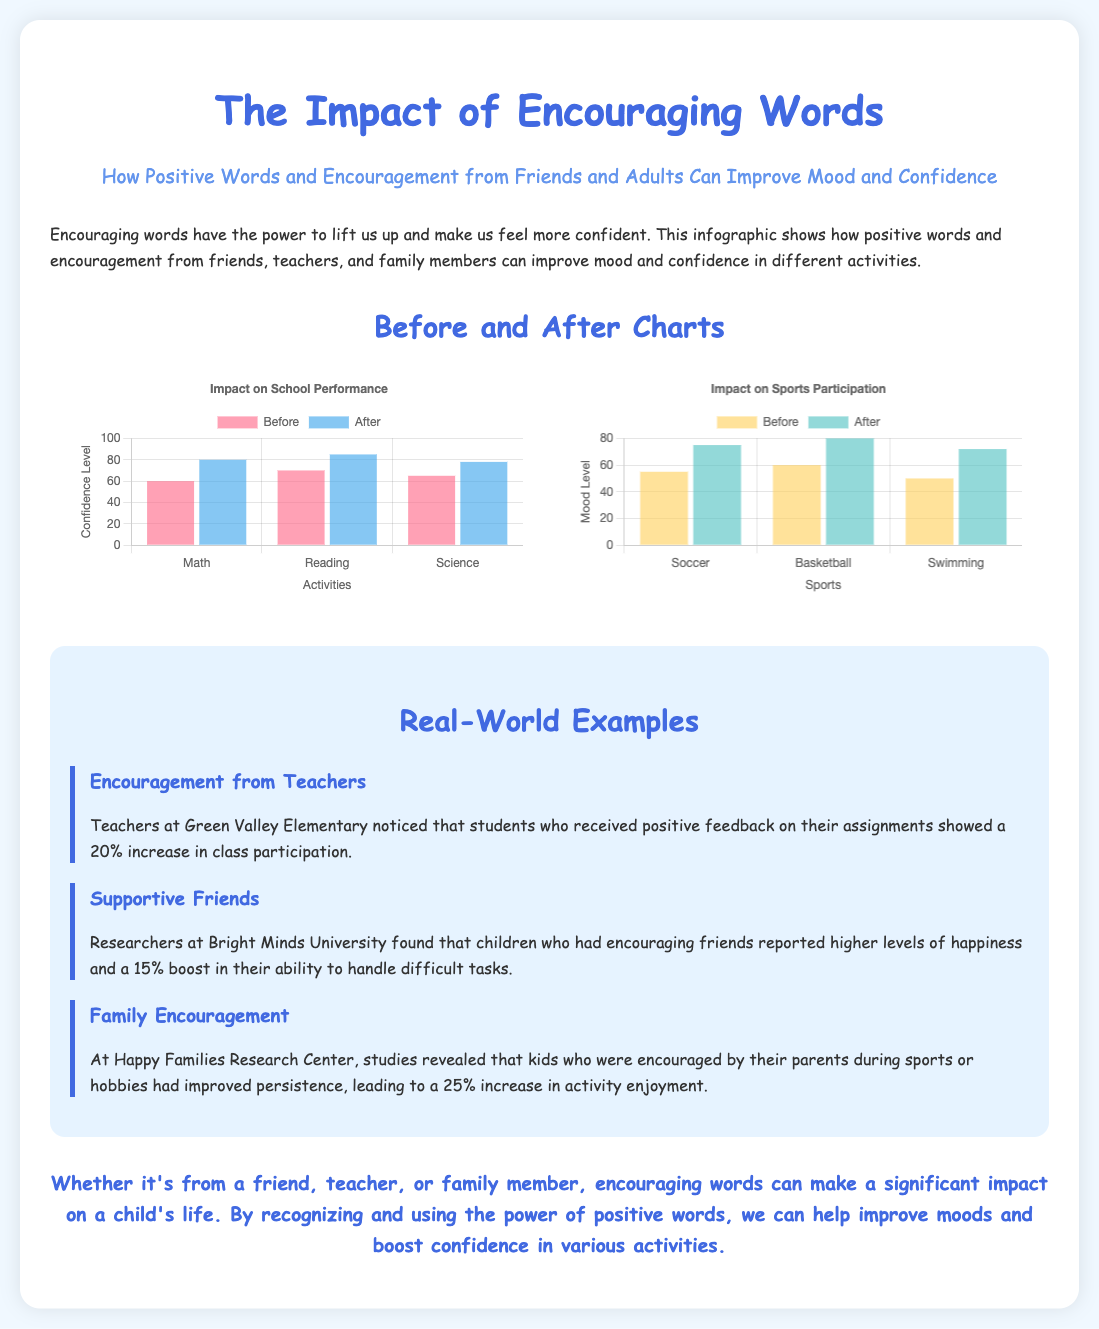What is the title of the infographic? The title is prominently displayed at the top of the document.
Answer: The Impact of Encouraging Words Which activities are mentioned in the school performance chart? The labels on the bar graph specify these activities.
Answer: Math, Reading, Science What percentage increase did students show in class participation after encouragement? The example given for teachers indicates this improvement percentage.
Answer: 20% What was the mood level for soccer before encouragement? The data point indicates the mood level for this sport in the bar graph.
Answer: 55 What is the height of the 'After' bar for swimming in the sports chart? This figure can be extracted from the data provided in the document.
Answer: 72 How much did children who had encouraging friends report in happiness levels? The described research provides this specific increase in happiness levels.
Answer: 15% What effect did family encouragement have on activity enjoyment? The study cited in the document provides this improvement statistic.
Answer: 25% What type of graph is used in both charts? This is determined by the visual representation of data in the charts.
Answer: Bar What was the confidence level for reading before encouragement? The specific number is indicated on the relevant bar in the graph.
Answer: 70 